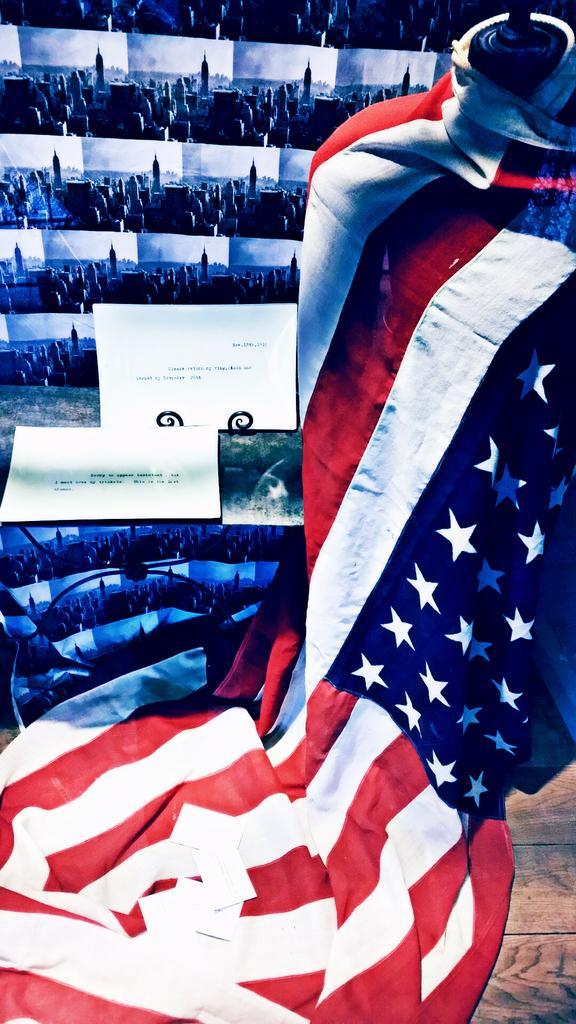Describe this image in one or two sentences. In this image we can see the flag on a mannequin. On the backside we can see a group of pictures of the buildings and some boards with text on it. 